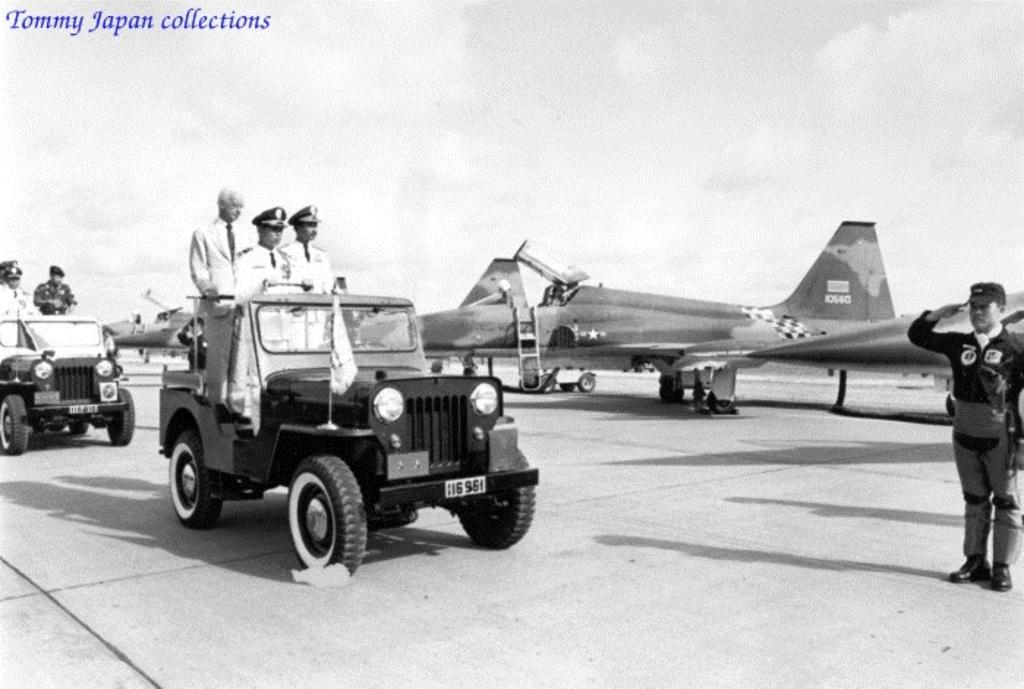What are the people in the image doing? The people are riding in a jeep. What other vehicle is present in the image? There is an aircraft in the image. What action is being performed by one of the people in the image? A person is standing and saluting the other people. What type of friction can be seen between the jeep and the ground in the image? There is no specific type of friction visible between the jeep and the ground in the image. What is the reaction of the people when they see the surprise in the image? There is no surprise present in the image, so it's not possible to determine the reaction of the people. 